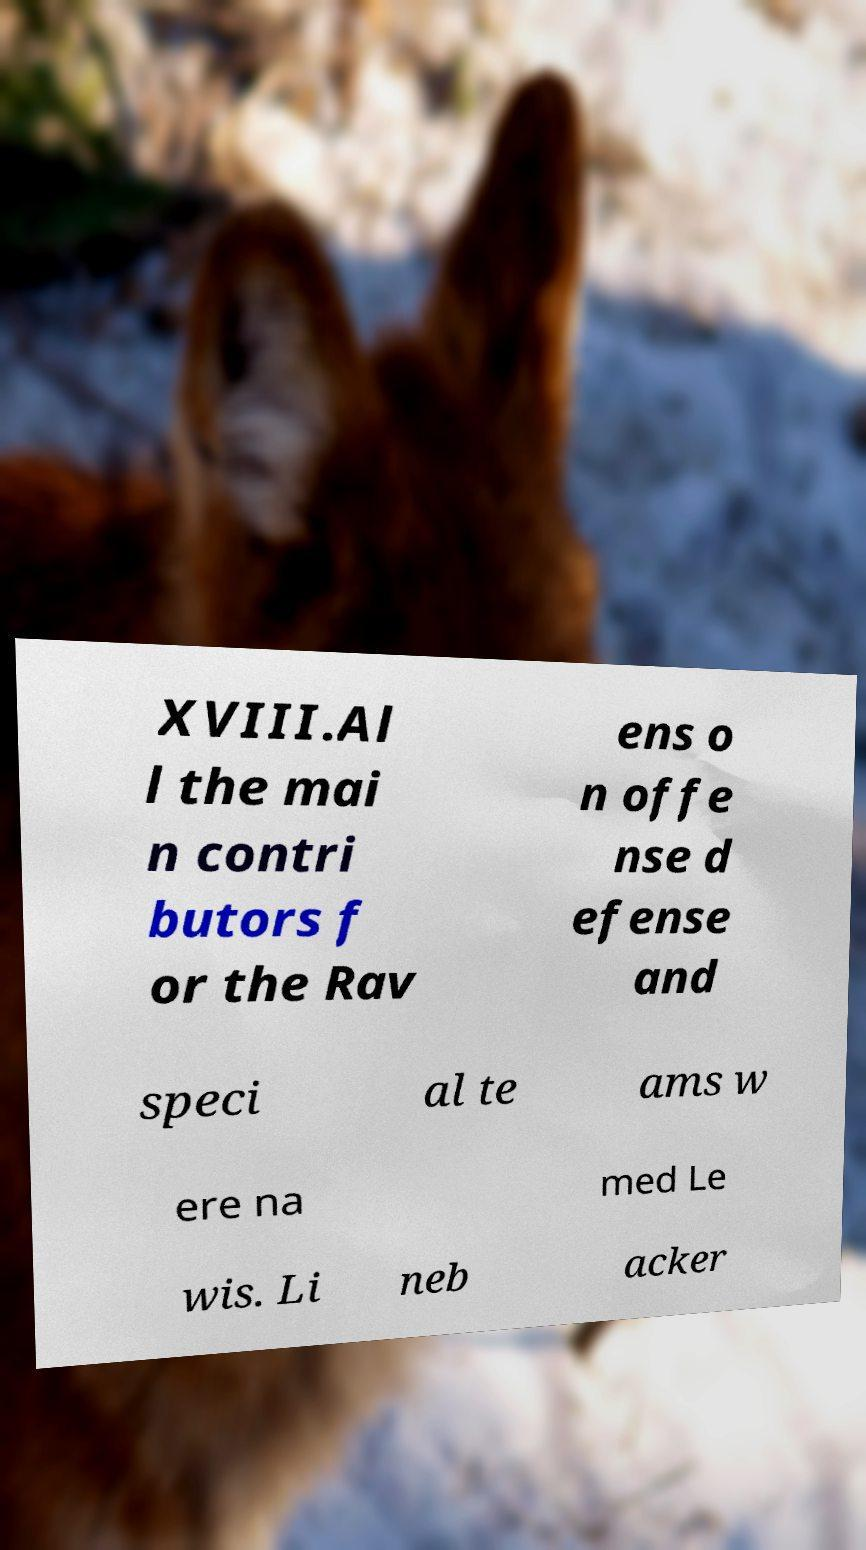Can you read and provide the text displayed in the image?This photo seems to have some interesting text. Can you extract and type it out for me? XVIII.Al l the mai n contri butors f or the Rav ens o n offe nse d efense and speci al te ams w ere na med Le wis. Li neb acker 